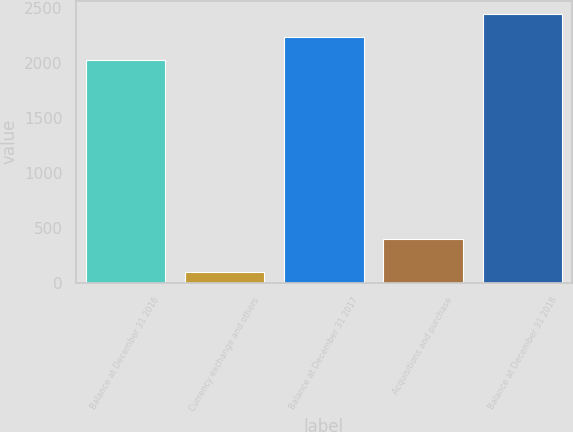Convert chart. <chart><loc_0><loc_0><loc_500><loc_500><bar_chart><fcel>Balance at December 31 2016<fcel>Currency exchange and others<fcel>Balance at December 31 2017<fcel>Acquisitions and purchase<fcel>Balance at December 31 2018<nl><fcel>2023.4<fcel>92<fcel>2232.8<fcel>394<fcel>2442.2<nl></chart> 